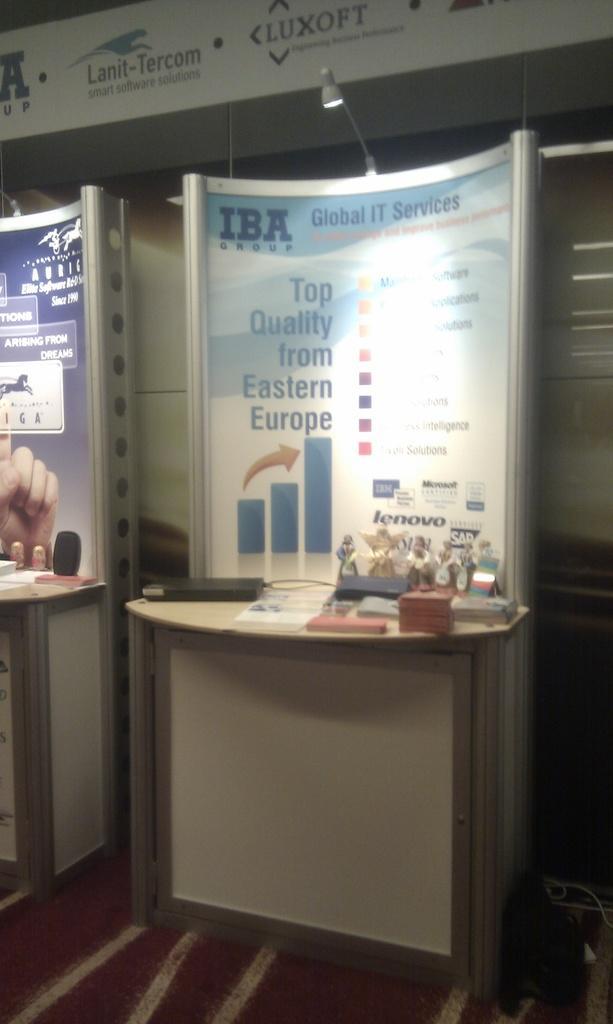Describe this image in one or two sentences. In this image I can see tables which has some objects. Here I can see boards. Here I can see something written on the boards. I can also see light on the board. 